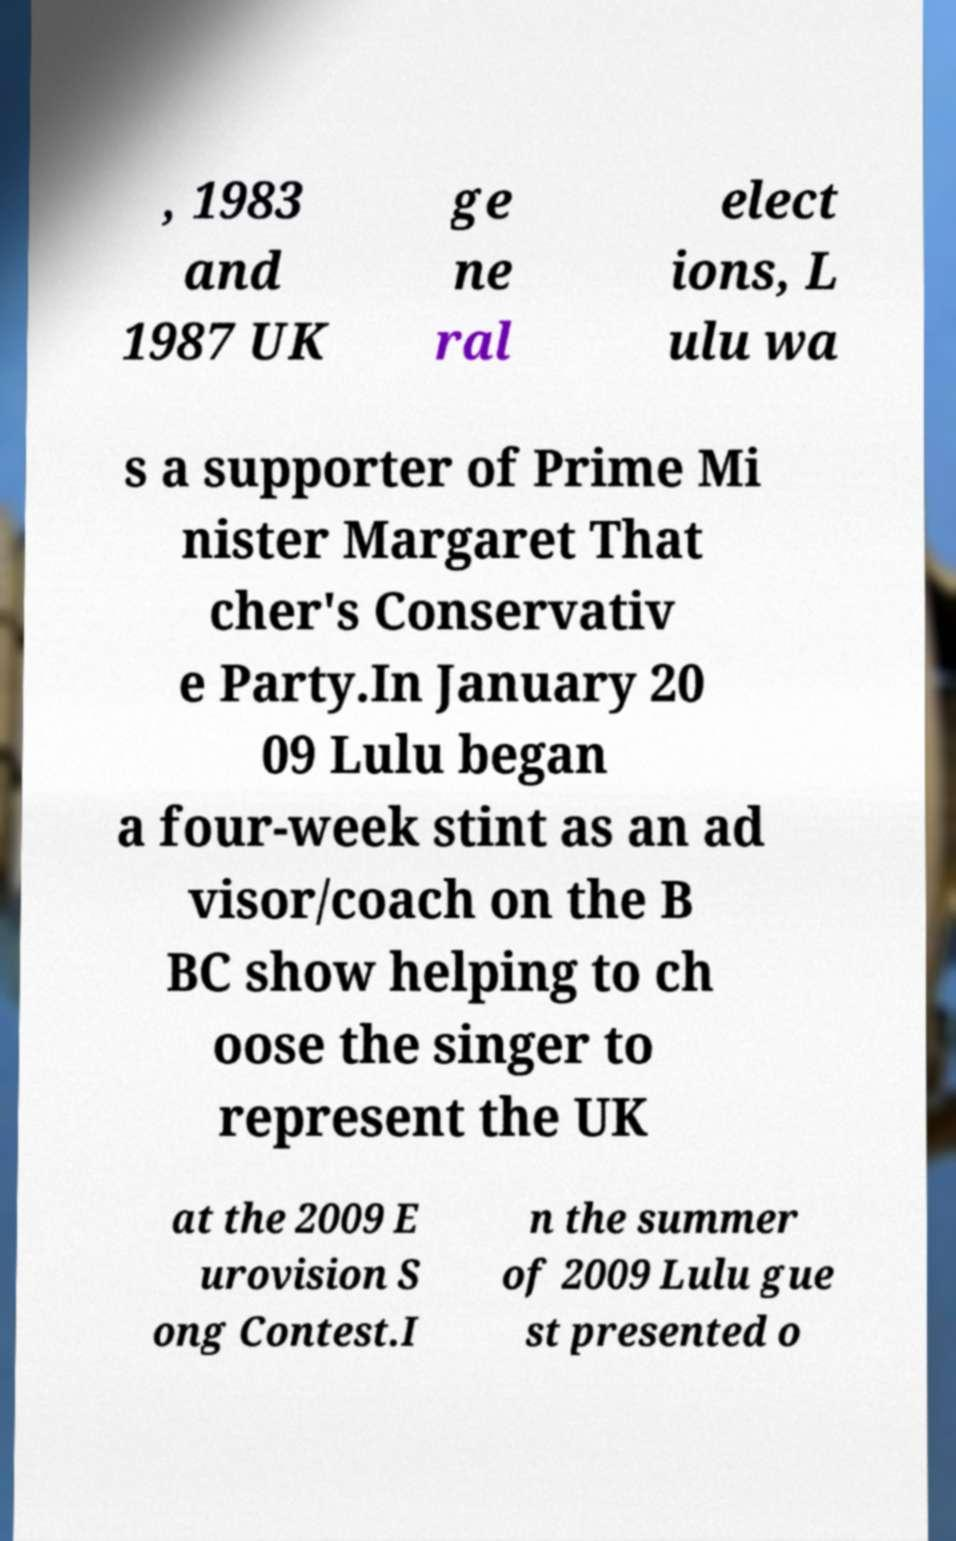Please identify and transcribe the text found in this image. , 1983 and 1987 UK ge ne ral elect ions, L ulu wa s a supporter of Prime Mi nister Margaret That cher's Conservativ e Party.In January 20 09 Lulu began a four-week stint as an ad visor/coach on the B BC show helping to ch oose the singer to represent the UK at the 2009 E urovision S ong Contest.I n the summer of 2009 Lulu gue st presented o 